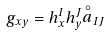Convert formula to latex. <formula><loc_0><loc_0><loc_500><loc_500>g _ { x y } = h ^ { I } _ { x } h ^ { J } _ { y } { \stackrel { \circ } { a } } _ { I J }</formula> 